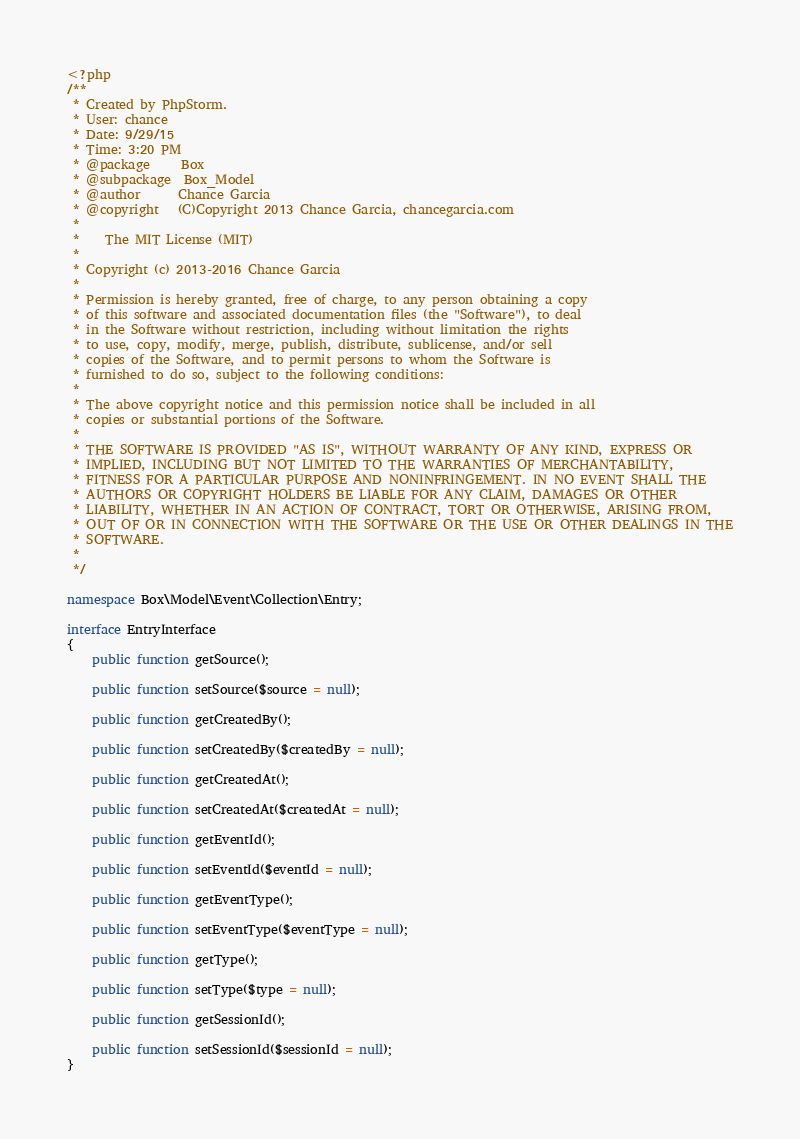<code> <loc_0><loc_0><loc_500><loc_500><_PHP_><?php
/**
 * Created by PhpStorm.
 * User: chance
 * Date: 9/29/15
 * Time: 3:20 PM
 * @package     Box
 * @subpackage  Box_Model
 * @author      Chance Garcia
 * @copyright   (C)Copyright 2013 Chance Garcia, chancegarcia.com
 *
 *    The MIT License (MIT)
 *
 * Copyright (c) 2013-2016 Chance Garcia
 *
 * Permission is hereby granted, free of charge, to any person obtaining a copy
 * of this software and associated documentation files (the "Software"), to deal
 * in the Software without restriction, including without limitation the rights
 * to use, copy, modify, merge, publish, distribute, sublicense, and/or sell
 * copies of the Software, and to permit persons to whom the Software is
 * furnished to do so, subject to the following conditions:
 *
 * The above copyright notice and this permission notice shall be included in all
 * copies or substantial portions of the Software.
 *
 * THE SOFTWARE IS PROVIDED "AS IS", WITHOUT WARRANTY OF ANY KIND, EXPRESS OR
 * IMPLIED, INCLUDING BUT NOT LIMITED TO THE WARRANTIES OF MERCHANTABILITY,
 * FITNESS FOR A PARTICULAR PURPOSE AND NONINFRINGEMENT. IN NO EVENT SHALL THE
 * AUTHORS OR COPYRIGHT HOLDERS BE LIABLE FOR ANY CLAIM, DAMAGES OR OTHER
 * LIABILITY, WHETHER IN AN ACTION OF CONTRACT, TORT OR OTHERWISE, ARISING FROM,
 * OUT OF OR IN CONNECTION WITH THE SOFTWARE OR THE USE OR OTHER DEALINGS IN THE
 * SOFTWARE.
 *
 */

namespace Box\Model\Event\Collection\Entry;

interface EntryInterface
{
    public function getSource();

    public function setSource($source = null);

    public function getCreatedBy();

    public function setCreatedBy($createdBy = null);

    public function getCreatedAt();

    public function setCreatedAt($createdAt = null);

    public function getEventId();

    public function setEventId($eventId = null);

    public function getEventType();

    public function setEventType($eventType = null);

    public function getType();

    public function setType($type = null);

    public function getSessionId();

    public function setSessionId($sessionId = null);
}</code> 